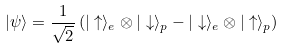<formula> <loc_0><loc_0><loc_500><loc_500>| \psi \rangle = \frac { 1 } { \sqrt { 2 } } \left ( | \uparrow \rangle _ { e } \otimes | \downarrow \rangle _ { p } - | \downarrow \rangle _ { e } \otimes | \uparrow \rangle _ { p } \right )</formula> 